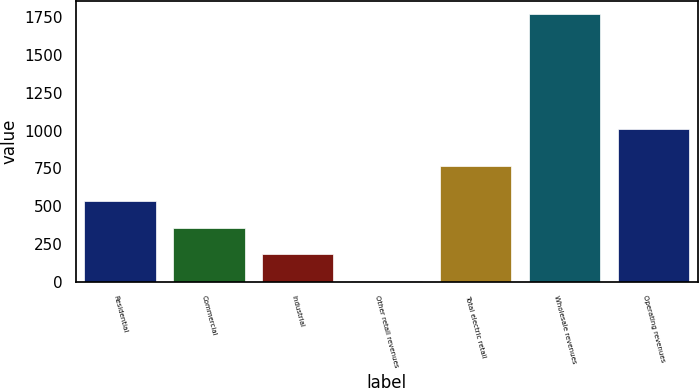Convert chart. <chart><loc_0><loc_0><loc_500><loc_500><bar_chart><fcel>Residential<fcel>Commercial<fcel>Industrial<fcel>Other retail revenues<fcel>Total electric retail<fcel>Wholesale revenues<fcel>Operating revenues<nl><fcel>534.1<fcel>357.4<fcel>180.7<fcel>4<fcel>763<fcel>1771<fcel>1008<nl></chart> 